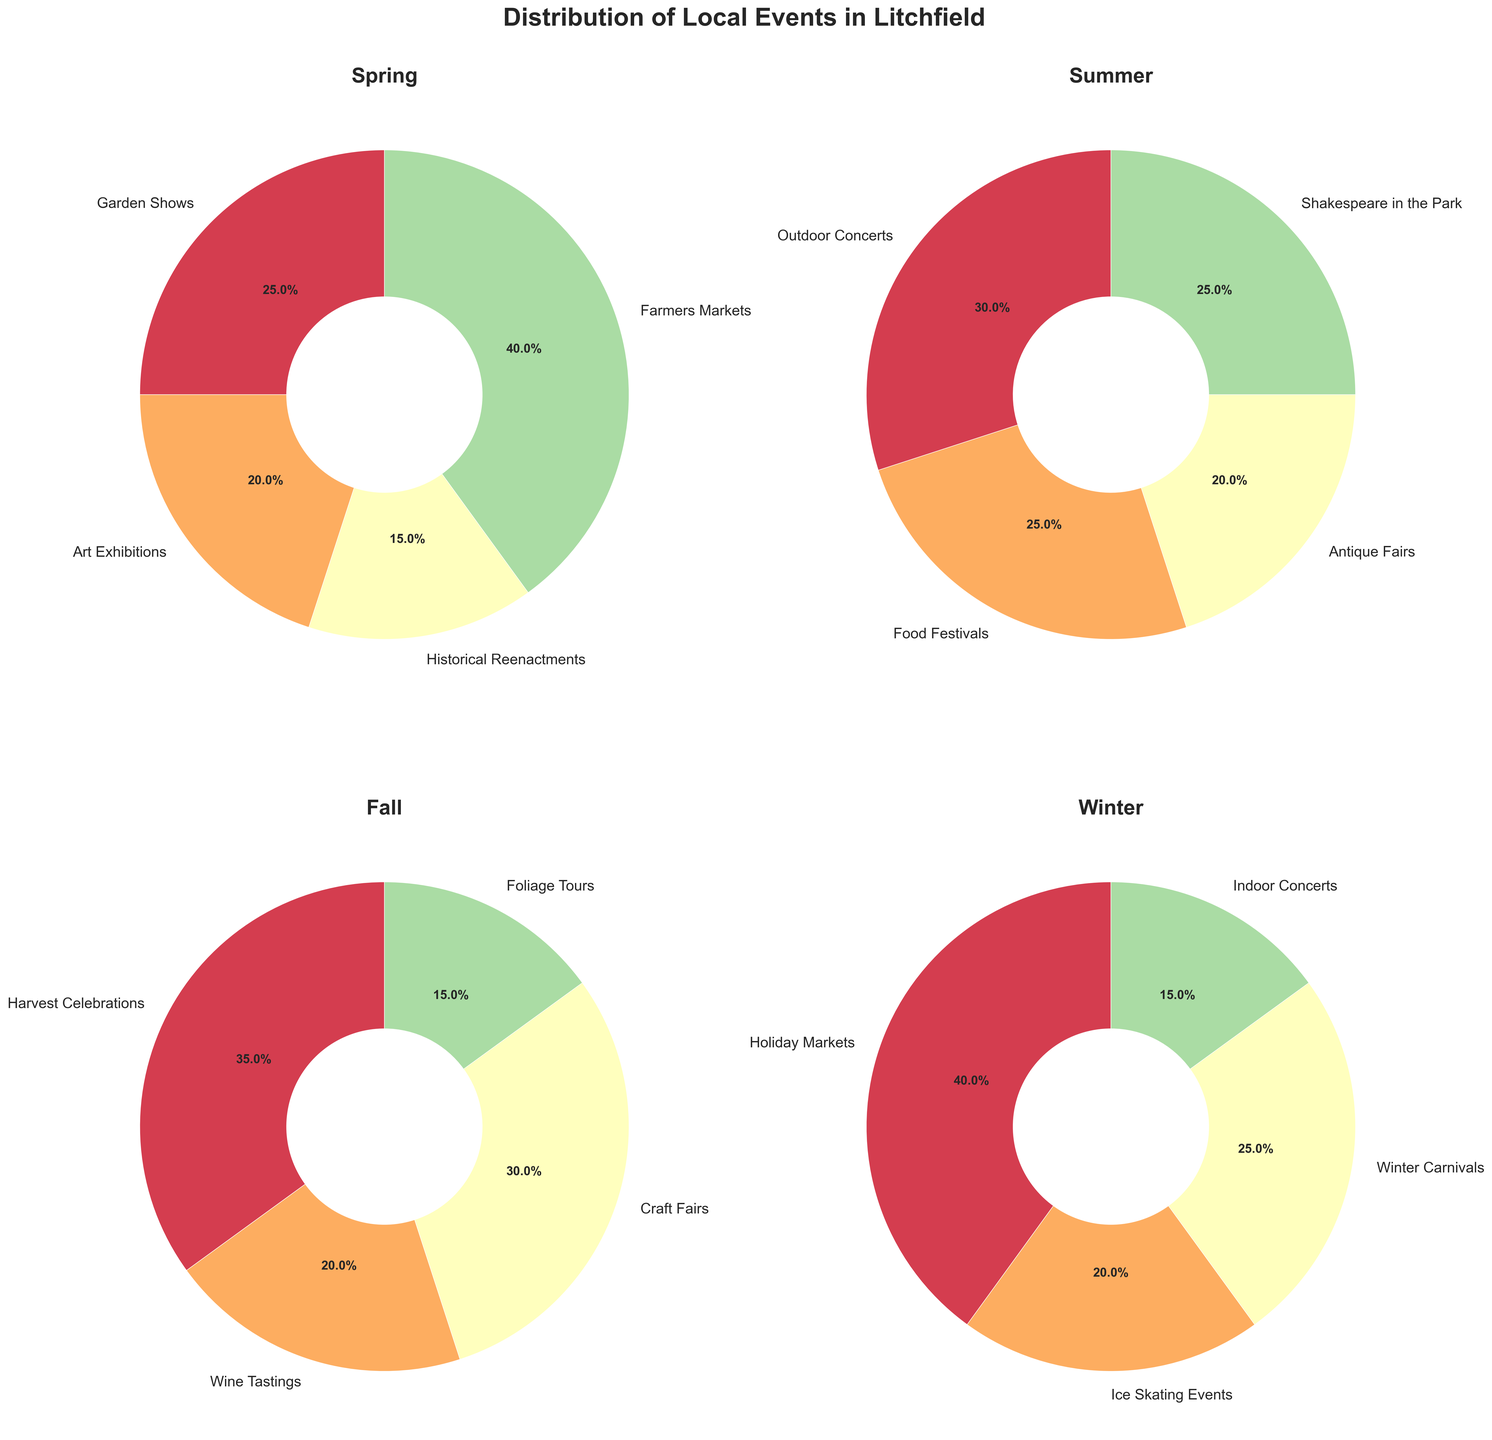What type of events have the highest percentage in Spring? By looking at the pie chart labeled "Spring," we can see that Farmers Markets take up the largest portion.
Answer: Farmers Markets Which event type has the smallest percentage in Summer? Observing the Summer pie chart, Antique Fairs have the smallest slice amongst all event types.
Answer: Antique Fairs What is the combined percentage of Holiday Markets and Winter Carnivals in Winter? First, check the Winter pie chart to find that Holiday Markets have 40% and Winter Carnivals have 25%. Adding them together gives 40% + 25% = 65%.
Answer: 65% How does the percentage of Garden Shows in Spring compare to Outdoor Concerts in Summer? Garden Shows in Spring have 25%, while Outdoor Concerts in Summer have 30%. Outdoor Concerts have a higher percentage than Garden Shows.
Answer: Outdoor Concerts have a higher percentage Are there more types of events in Fall or Winter? Count the event types in both seasons by looking at their respective pie charts. Fall has 4 types (Harvest Celebrations, Wine Tastings, Craft Fairs, Foliage Tours) and Winter also has 4 types (Holiday Markets, Ice Skating Events, Winter Carnivals, Indoor Concerts). Hence, both seasons have the same number of event types.
Answer: The same What percentage of events in Fall are related to Celebrations and Tastings? Check the Fall pie chart to see that Harvest Celebrations are 35% and Wine Tastings are 20%. The sum is 35% + 20% = 55%.
Answer: 55% Which season has the highest percentage dedicated to a single event type? By comparing the largest slices in each pie chart: Spring (40% Farmers Markets), Summer (30% Outdoor Concerts), Fall (35% Harvest Celebrations), Winter (40% Holiday Markets), observe that Spring and Winter both have the highest single event percentage at 40%.
Answer: Spring and Winter What is the difference in percentage between the largest and smallest event types in Spring? In the Spring pie chart, the largest event type is Farmers Markets at 40% and the smallest event type is Historical Reenactments at 15%. The difference is 40% - 15% = 25%.
Answer: 25% What is the total number of event types covered in the subplots? Count the distinct event types in each season's pie chart: Spring (4 types), Summer (4 types), Fall (4 types), Winter (4 types). Sum them up 4 + 4 + 4 + 4 = 16, but since some events might repeat across seasons, we should list the unique event types to find the correct total. List: Garden Shows, Art Exhibitions, Historical Reenactments, Farmers Markets, Outdoor Concerts, Food Festivals, Antique Fairs, Shakespeare in the Park, Harvest Celebrations, Wine Tastings, Craft Fairs, Foliage Tours, Holiday Markets, Ice Skating Events, Winter Carnivals, Indoor Concerts. By listing and checking for uniqueness, there are indeed 16 unique types.
Answer: 16 